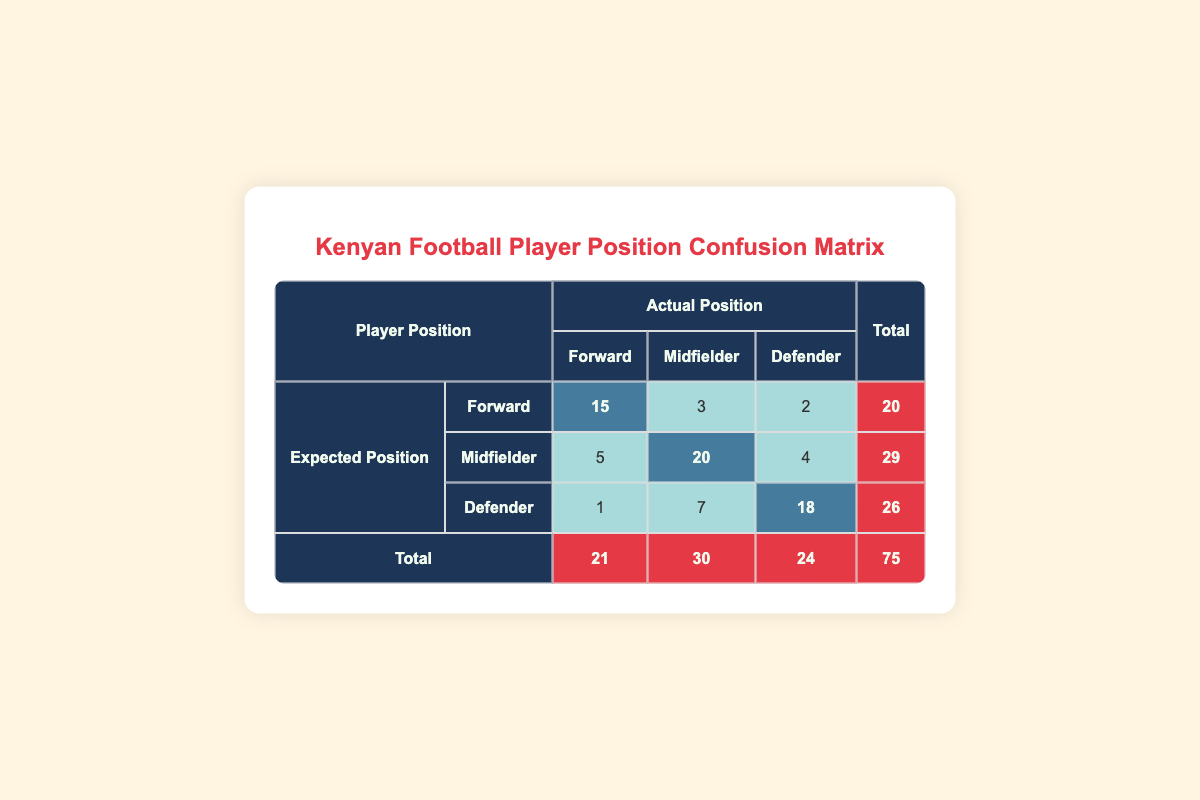What is the total number of players expected to be forwards? To find the total number of players who were expected to be forwards, we look at the "Total" column corresponding to the "Forward" row. It shows a count of 20 players.
Answer: 20 How many players were actually defenders but expected to be midfielders? We can find this by looking at the "Defender" row and "Midfielder" column. The count there shows that 7 players were expected to be midfielders but actually played as defenders.
Answer: 7 What is the total number of players who were expected to be defenders? This is found by adding the counts in the "Total" row corresponding to the "Defender" column, which is 26 players in total expected to be defenders.
Answer: 26 Is the number of players who were expected to be forwards equal to the number of players who were actually defenders? From the table, 20 players were expected to be forwards and 24 players were actually defenders. Since 20 does not equal 24, the answer is no.
Answer: No What percentage of players expected to be defenders actually played as defenders? The number of players who were expected to be defenders is 26 (the total for the defender row). The number of those who played as defenders is 18. The percentage is calculated as (18/26) * 100, which equals approximately 69.2%.
Answer: 69.2% What is the difference in counts between players expected to be midfielders and those expected to be forwards? We find the total expected players count for midfielders as 29 and for forwards as 20. The difference is calculated as 29 - 20 = 9.
Answer: 9 How many players were expected to play as forwards but actually played as defenders? The count of players who were expected to be forwards and actually played as defenders is found in the "Defender" column under the "Forward" row, which shows a count of 2 players.
Answer: 2 What is the ratio of players who were accurately placed in their expected position compared to those who were not? To find this, we sum the counts of players accurately placed (15 + 20 + 18 = 53) and those who were not (3 + 2 + 5 + 4 + 7 + 1 = 22). The ratio is 53:22.
Answer: 53:22 